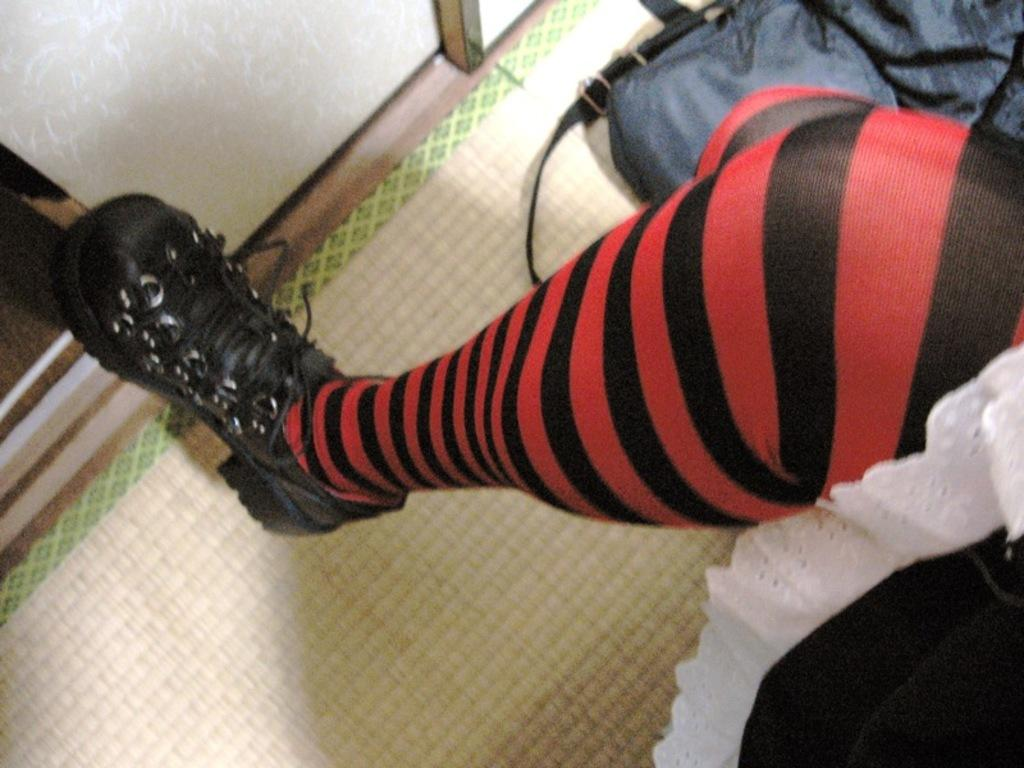What part of a person's body is visible in the foreground of the image? There is a person's leg in the foreground of the image. What object can be seen at the top of the image? There is a bag at the top of the image. Where is the door located in the image? The door is on the left side of the image. What time of day is it in the image, given that the person is in bed? There is no bed present in the image, and therefore it cannot be determined what time of day it is based on the person's bed. 